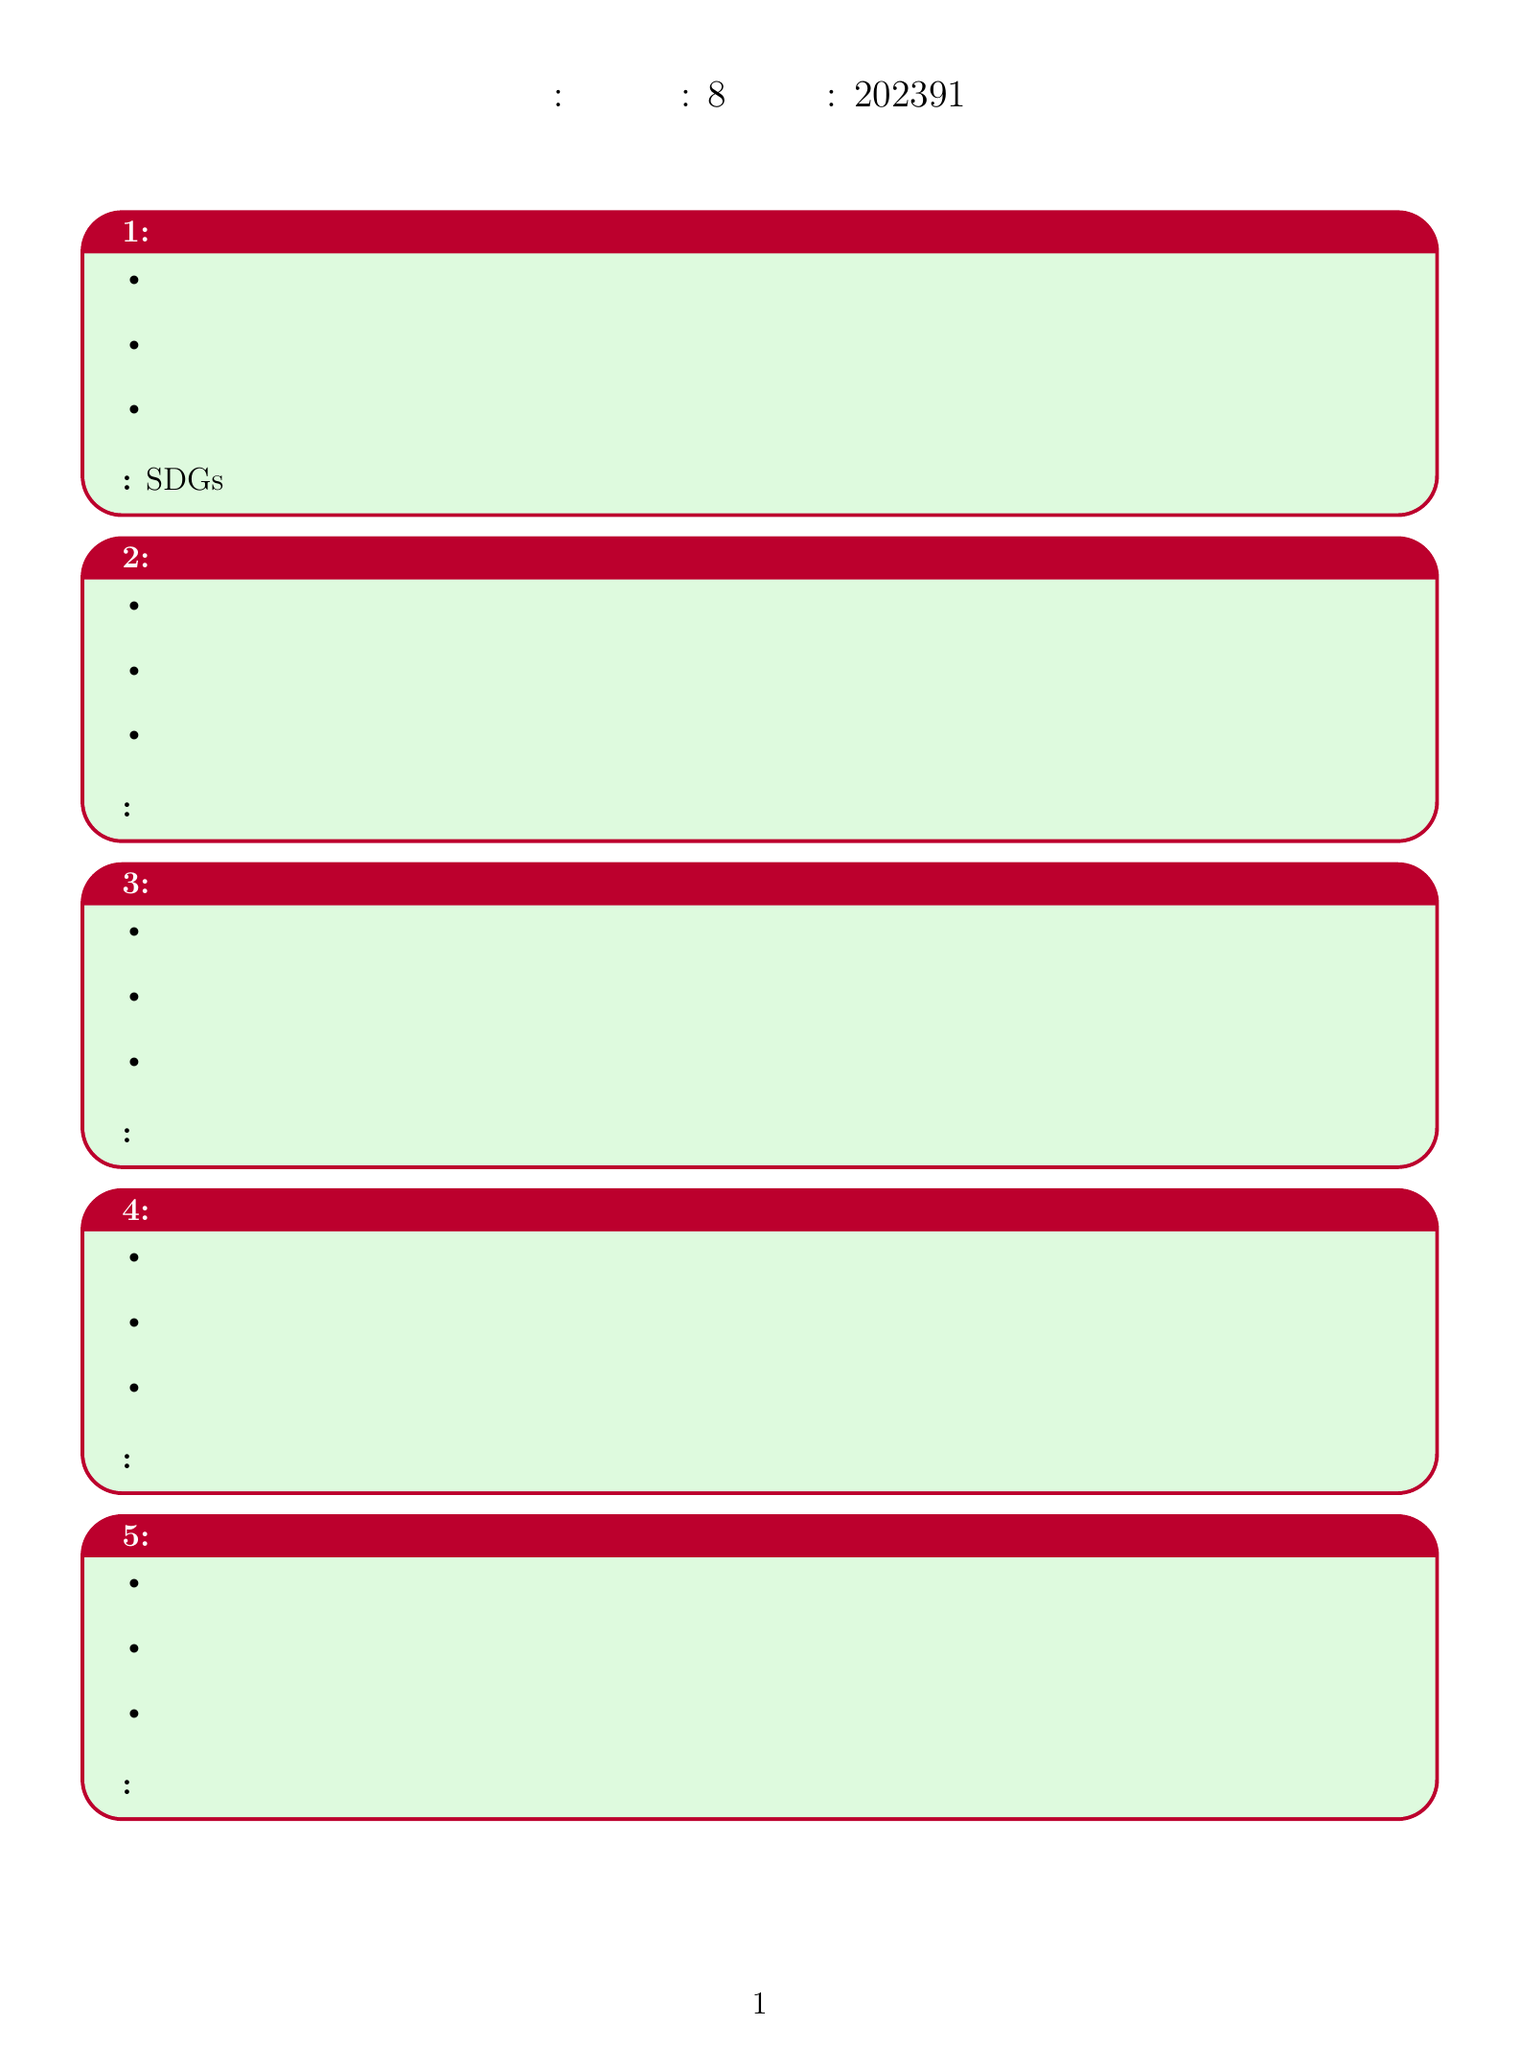What is the course name? The course name is stated at the beginning of the document as "Sustainable Development and Renewable Energy in Japan."
Answer: Sustainable Development and Renewable Energy in Japan Who is the instructor? The document provides the name of the instructor as "Dr. Yuki Yamamoto."
Answer: Dr. Yuki Yamamoto What is the duration of the course? The duration of the course is mentioned as "8 weeks."
Answer: 8 weeks When does the course start? The start date of the course is provided as "2023-09-01."
Answer: 2023-09-01 What is the assignment for week 3? The assignment for week 3 is clearly listed as "Group discussion on local climate change effects."
Answer: Group discussion on local climate change effects How many modules are there in the course? The number of modules is indicated by the weekly breakdown, which adds up to 8 weeks.
Answer: 8 modules Which renewable energy source is discussed in week 2? Week 2 focuses on several topics, one of which is "Wind Energy Potential."
Answer: Wind Energy Potential What is the title of the recommended reading by Kimiko Hirata? The recommended reading by Kimiko Hirata is "脱炭素革命への挑戦."
Answer: 脱炭素革命への挑戦 What is the assignment for the final week? The final week has the assignment stated as "Final project: Develop a local sustainability action plan."
Answer: Final project: Develop a local sustainability action plan 